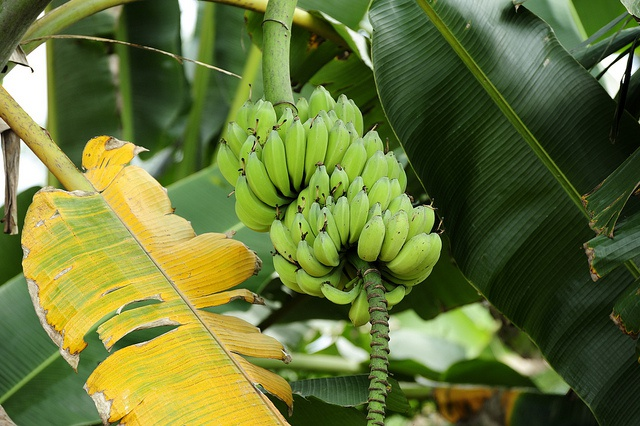Describe the objects in this image and their specific colors. I can see a banana in darkgreen, lightgreen, and olive tones in this image. 